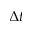<formula> <loc_0><loc_0><loc_500><loc_500>\Delta t</formula> 